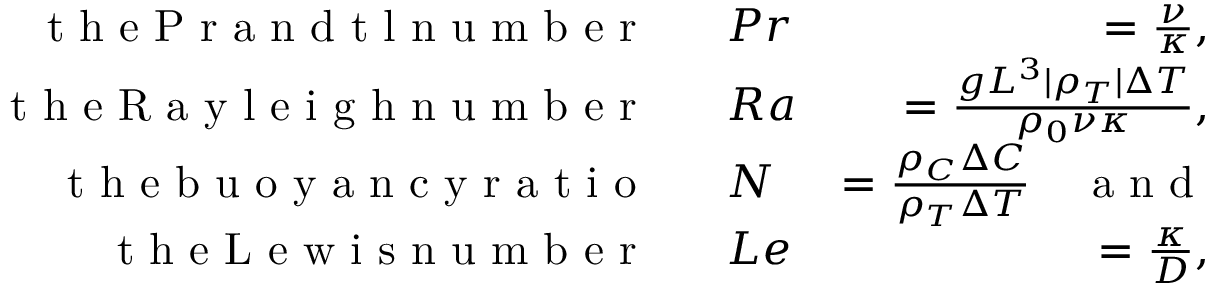<formula> <loc_0><loc_0><loc_500><loc_500>\begin{array} { r l r } { t h e P r a n d t \ln u m b e r } & P r } & { = \frac { \nu } { \kappa } , } \\ { t h e R a y l e i g h n u m b e r } & R a } & { = \frac { g L ^ { 3 } | \rho _ { T } | \Delta T } { \rho _ { 0 } \nu \kappa } , } \\ { t h e b u o y a n c y r a t i o } & N } & { = \frac { \rho _ { C } \Delta C } { \rho _ { T } \Delta T } \quad a n d } \\ { t h e L e w i s n u m b e r } & L e } & { = \frac { \kappa } { D } , } \end{array}</formula> 